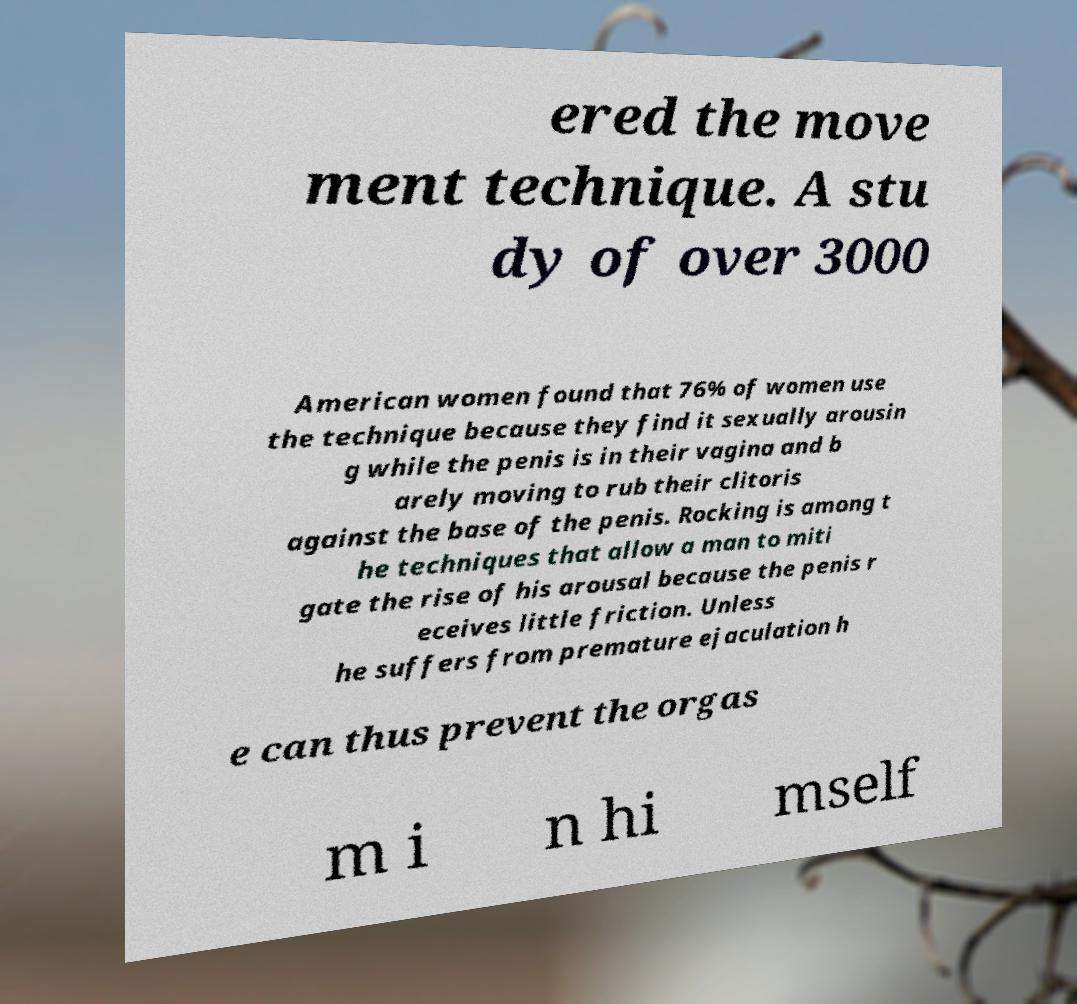Could you assist in decoding the text presented in this image and type it out clearly? ered the move ment technique. A stu dy of over 3000 American women found that 76% of women use the technique because they find it sexually arousin g while the penis is in their vagina and b arely moving to rub their clitoris against the base of the penis. Rocking is among t he techniques that allow a man to miti gate the rise of his arousal because the penis r eceives little friction. Unless he suffers from premature ejaculation h e can thus prevent the orgas m i n hi mself 